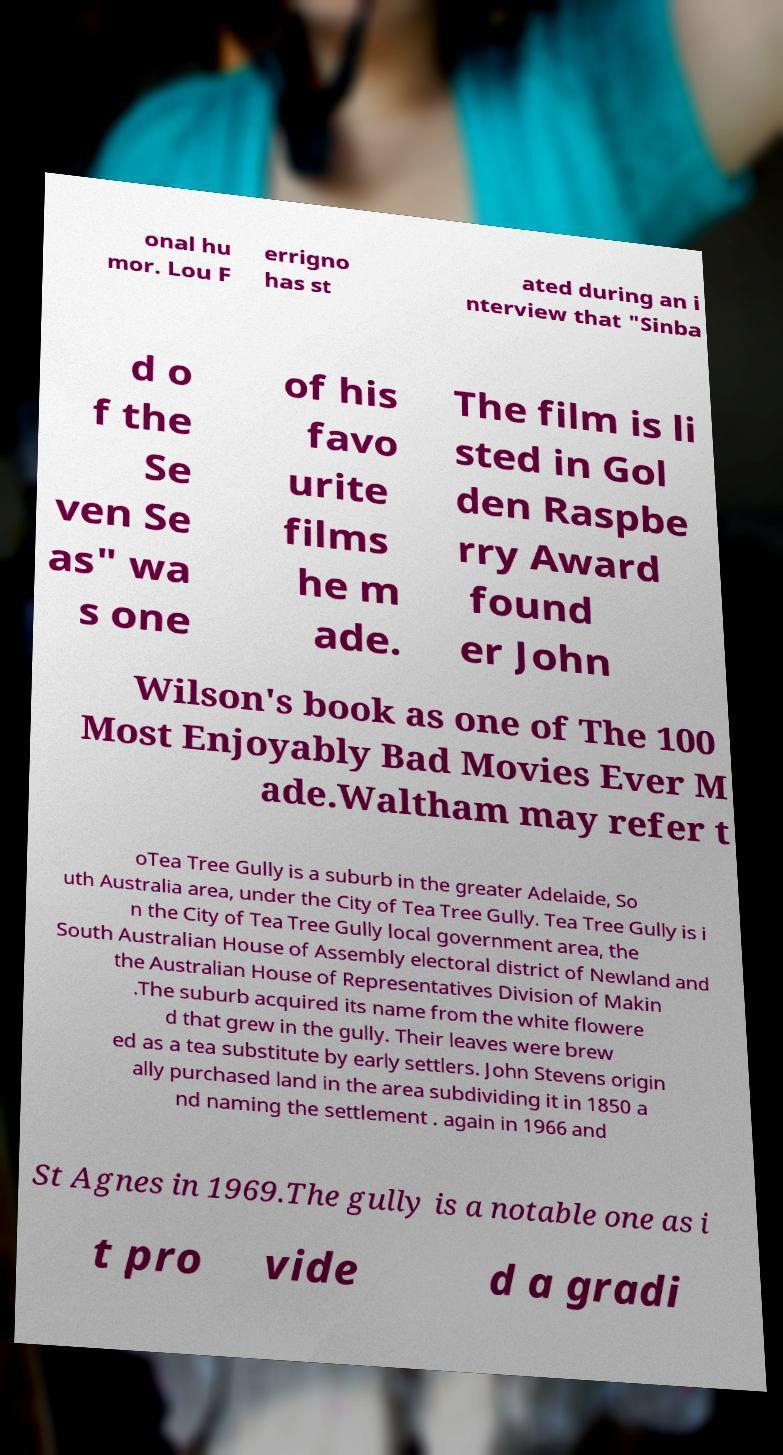Can you read and provide the text displayed in the image?This photo seems to have some interesting text. Can you extract and type it out for me? onal hu mor. Lou F errigno has st ated during an i nterview that "Sinba d o f the Se ven Se as" wa s one of his favo urite films he m ade. The film is li sted in Gol den Raspbe rry Award found er John Wilson's book as one of The 100 Most Enjoyably Bad Movies Ever M ade.Waltham may refer t oTea Tree Gully is a suburb in the greater Adelaide, So uth Australia area, under the City of Tea Tree Gully. Tea Tree Gully is i n the City of Tea Tree Gully local government area, the South Australian House of Assembly electoral district of Newland and the Australian House of Representatives Division of Makin .The suburb acquired its name from the white flowere d that grew in the gully. Their leaves were brew ed as a tea substitute by early settlers. John Stevens origin ally purchased land in the area subdividing it in 1850 a nd naming the settlement . again in 1966 and St Agnes in 1969.The gully is a notable one as i t pro vide d a gradi 